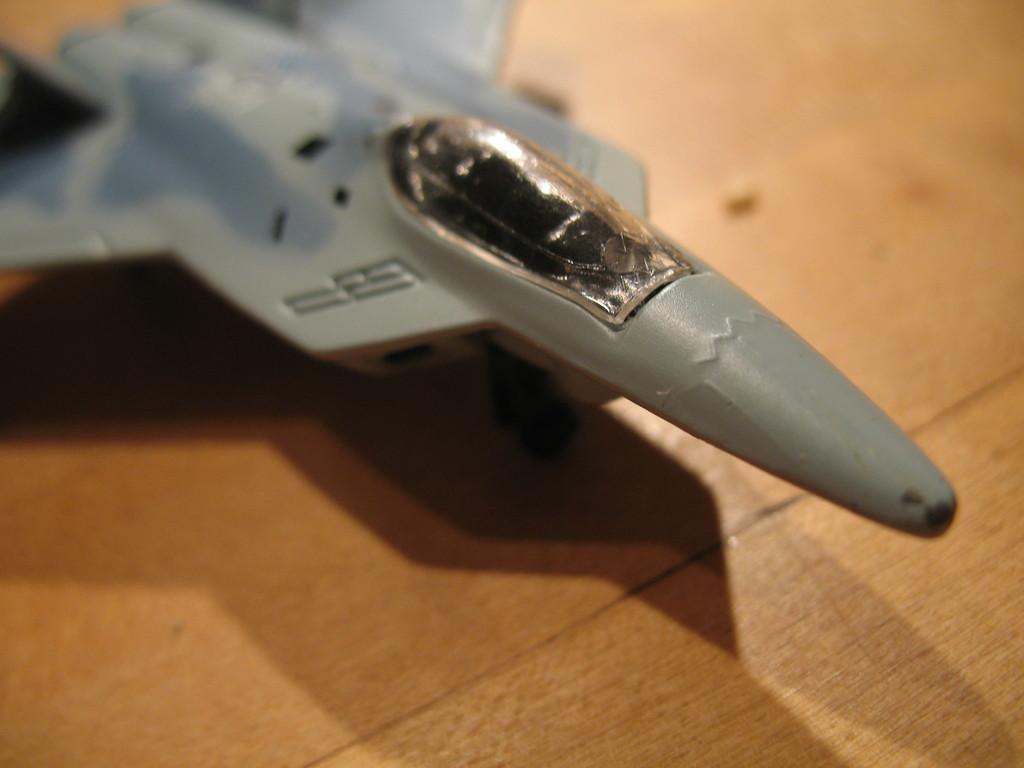What is the main subject of the image? The main subject of the image is an aircraft toy. Can you describe the location of the aircraft toy in the image? The aircraft toy is on a surface in the image. What type of discussion is taking place between the toys in the image? There are no toys engaged in a discussion in the image, as it only features an aircraft toy on a surface. 